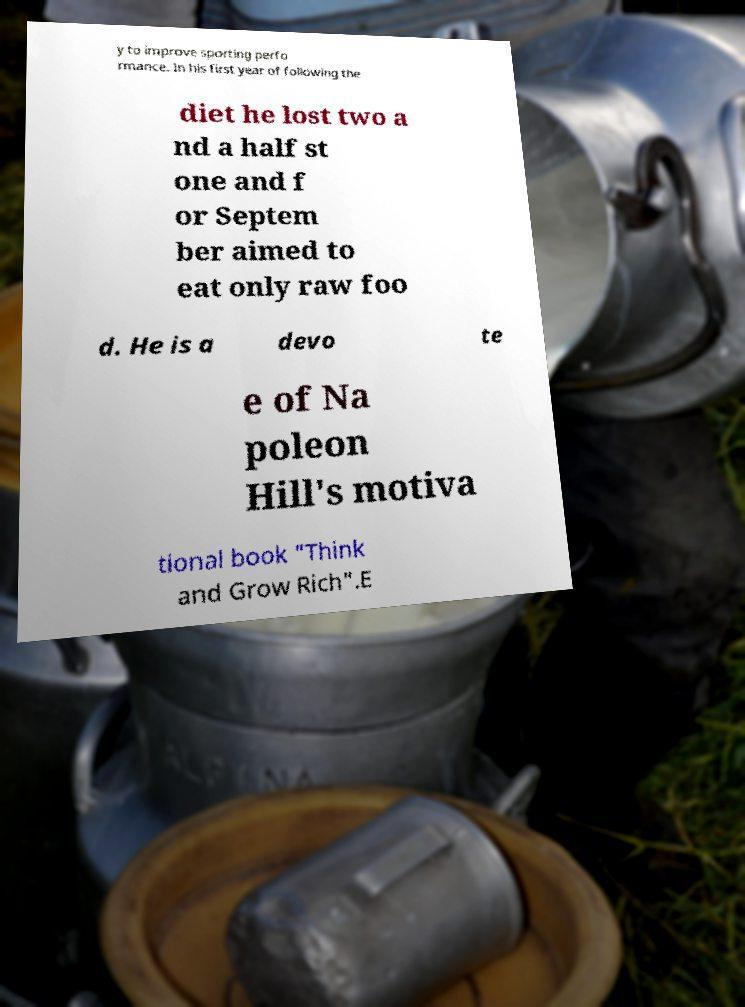Please read and relay the text visible in this image. What does it say? y to improve sporting perfo rmance. In his first year of following the diet he lost two a nd a half st one and f or Septem ber aimed to eat only raw foo d. He is a devo te e of Na poleon Hill's motiva tional book "Think and Grow Rich".E 